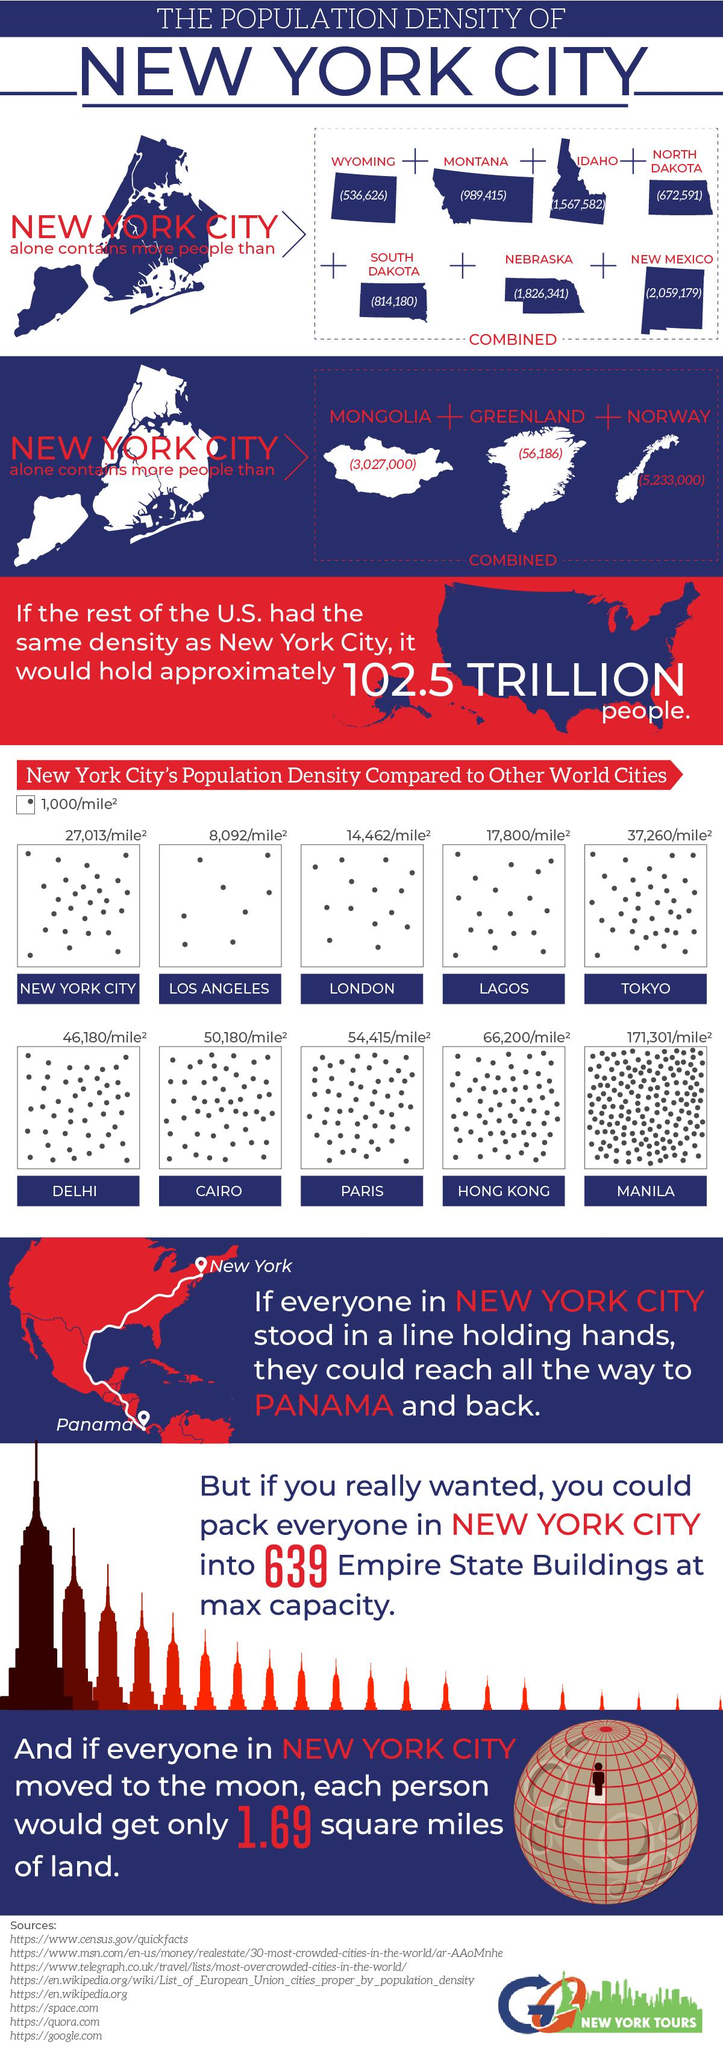Mention a couple of crucial points in this snapshot. Hong Kong is the second-most densely populated city in the world. 